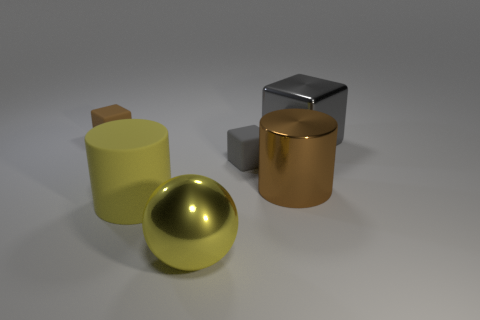Are there any reflections on the objects that tell us more about the environment? Yes, the reflective surfaces, especially on the glossy yellow cylinder and the sphere, show some subtle reflections of the environment. The muted reflections suggest the surrounding area is likely devoid of strong, distinct colors or shapes, indicating an uncluttered space. 